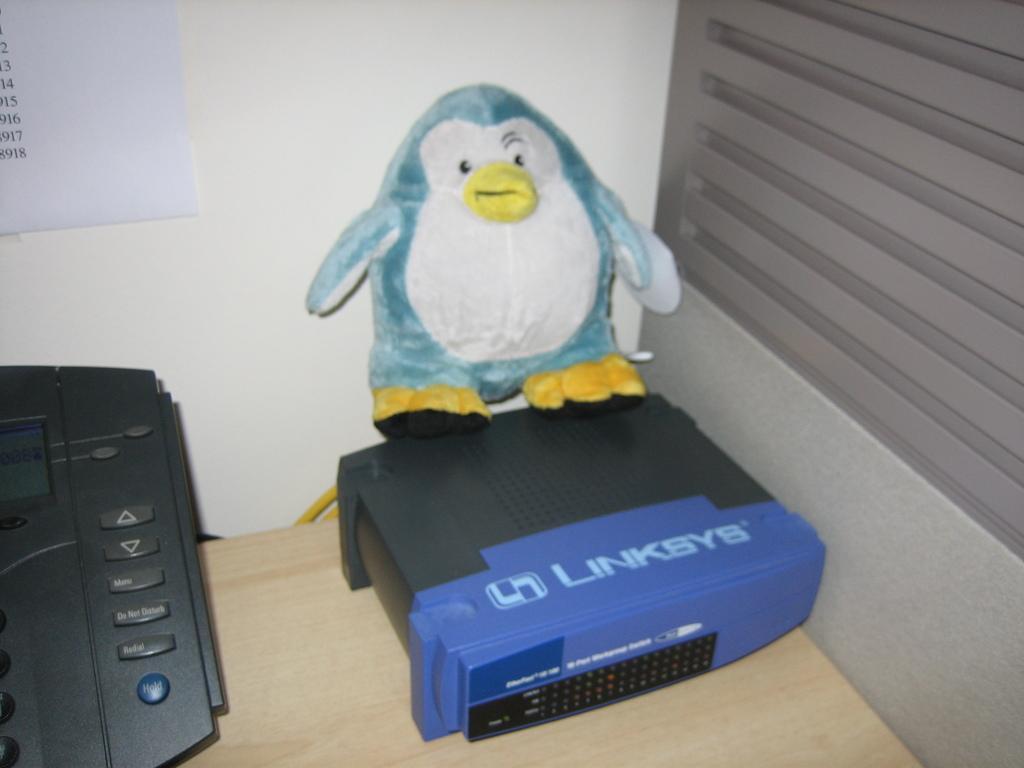Please provide a concise description of this image. In this image in front there is a table and on top of the table there is a landline phone. There is a depiction of a penguin and there is an object. Behind the table there is a paper attached to the wall. 